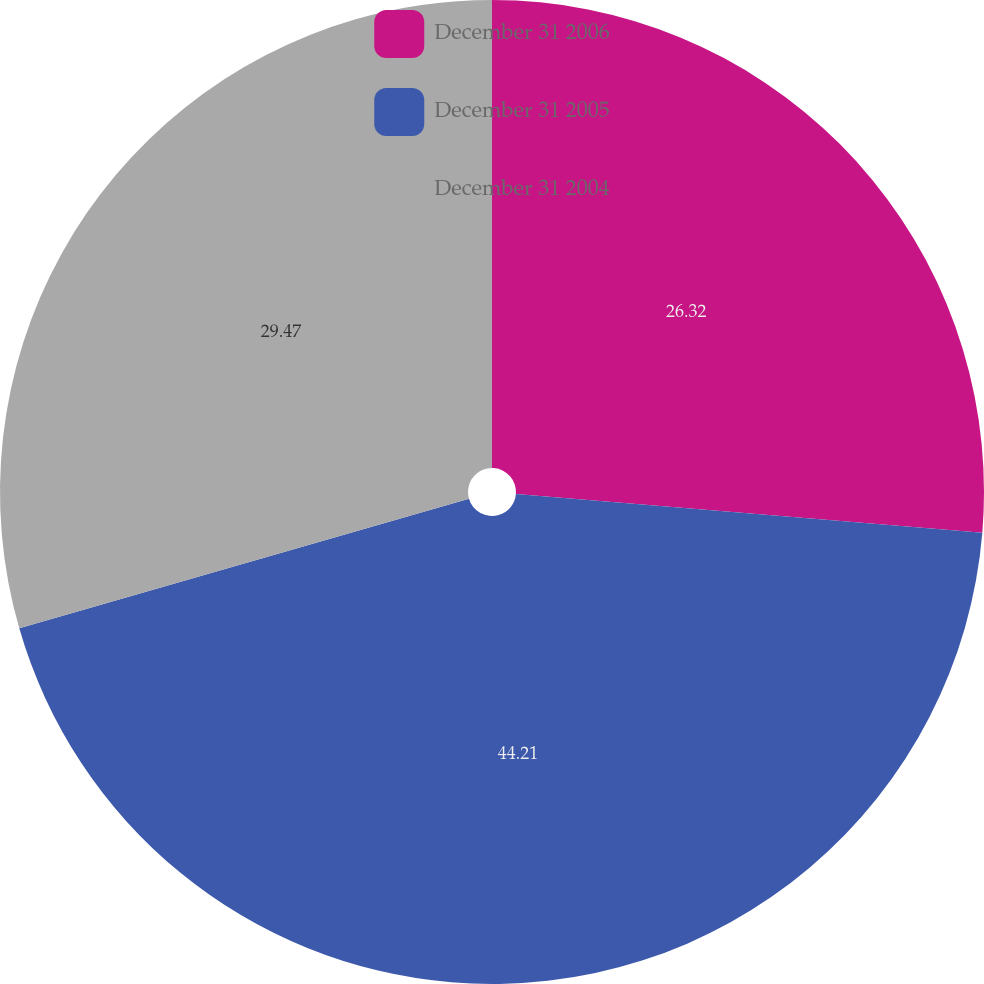<chart> <loc_0><loc_0><loc_500><loc_500><pie_chart><fcel>December 31 2006<fcel>December 31 2005<fcel>December 31 2004<nl><fcel>26.32%<fcel>44.21%<fcel>29.47%<nl></chart> 